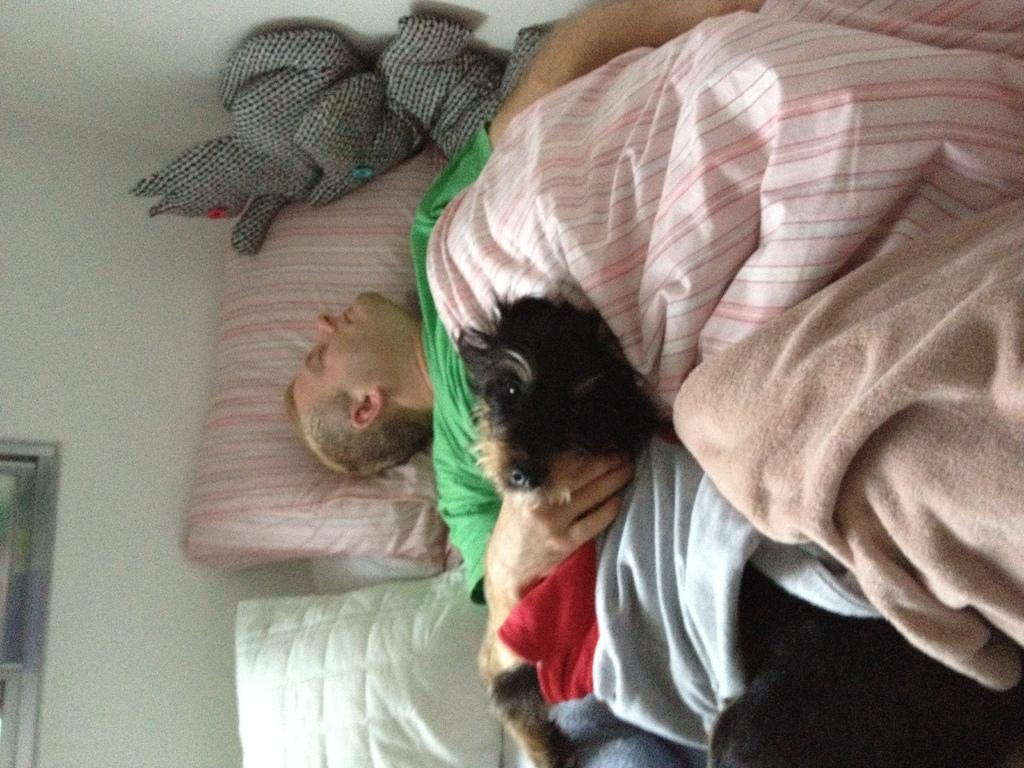What is the person in the image wearing? The person is wearing a green t-shirt in the image. What is the person doing in the image? The person is sleeping on the bed. Is there any other living creature in the image? Yes, there is a dog sleeping on the bed. What else can be seen on the bed? Clothes and pillows are visible on the bed. What color is the wall in the image? The wall is white in color. What type of lunch is being served in the office in the image? There is no mention of lunch or an office in the image; it features a person and a dog sleeping on a bed. 